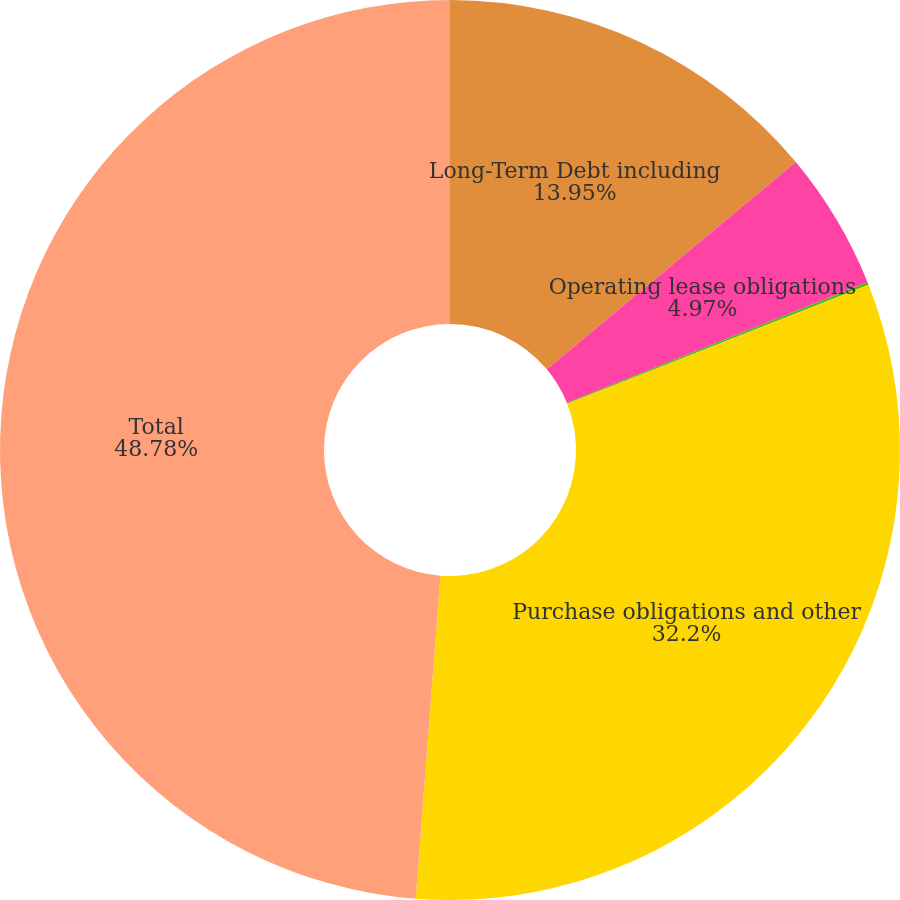Convert chart to OTSL. <chart><loc_0><loc_0><loc_500><loc_500><pie_chart><fcel>Long-Term Debt including<fcel>Operating lease obligations<fcel>Capital lease obligations (3)<fcel>Purchase obligations and other<fcel>Total<nl><fcel>13.95%<fcel>4.97%<fcel>0.1%<fcel>32.2%<fcel>48.79%<nl></chart> 